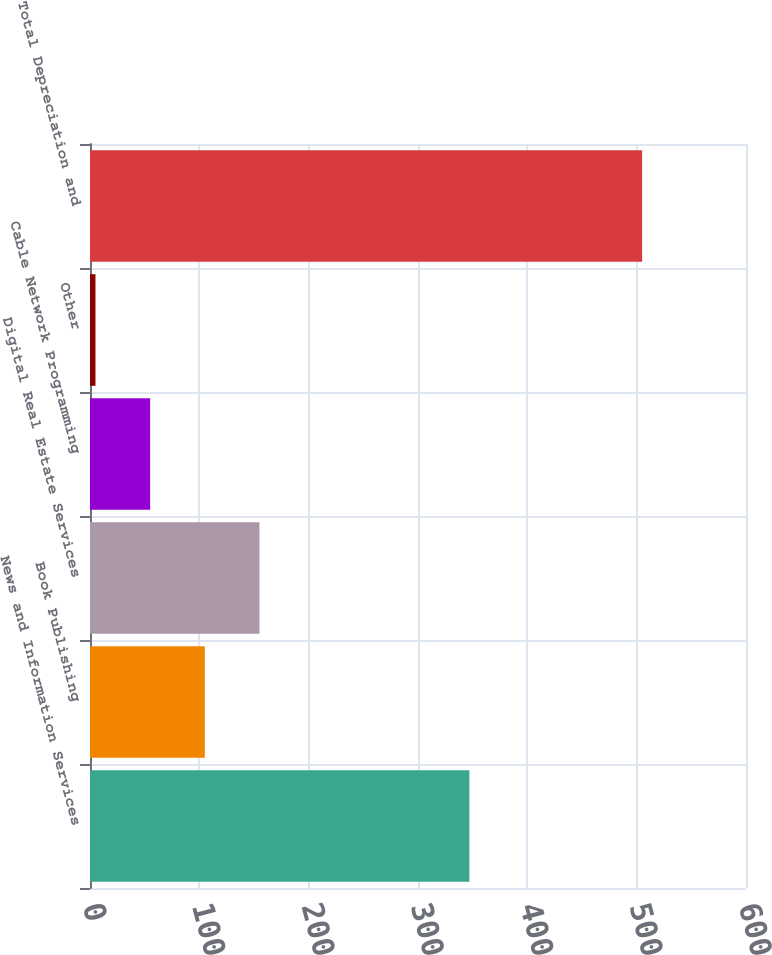<chart> <loc_0><loc_0><loc_500><loc_500><bar_chart><fcel>News and Information Services<fcel>Book Publishing<fcel>Digital Real Estate Services<fcel>Cable Network Programming<fcel>Other<fcel>Total Depreciation and<nl><fcel>347<fcel>105<fcel>155<fcel>55<fcel>5<fcel>505<nl></chart> 